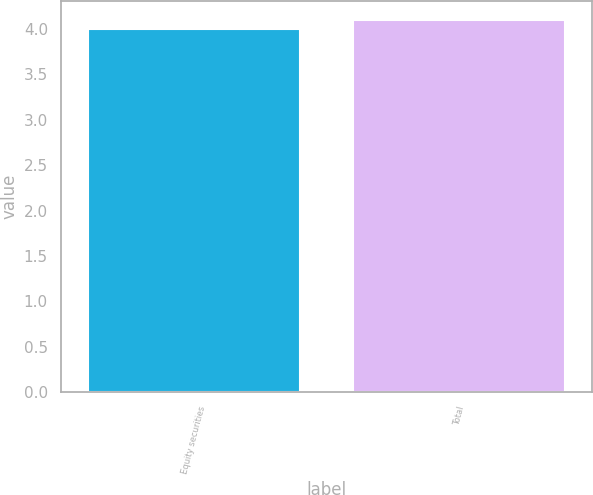Convert chart to OTSL. <chart><loc_0><loc_0><loc_500><loc_500><bar_chart><fcel>Equity securities<fcel>Total<nl><fcel>4<fcel>4.1<nl></chart> 